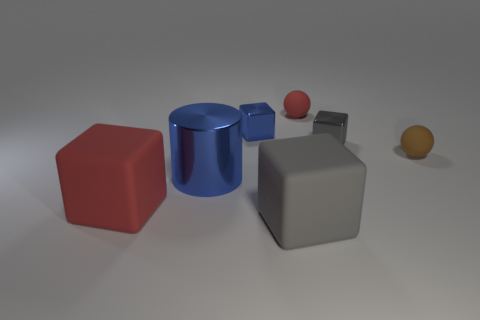There is a tiny gray thing; is its shape the same as the red matte thing that is left of the blue block?
Give a very brief answer. Yes. There is a cube that is left of the large gray thing and in front of the tiny blue block; how big is it?
Your response must be concise. Large. What shape is the tiny gray object?
Your answer should be compact. Cube. There is a matte ball to the left of the tiny brown sphere; is there a cube on the right side of it?
Make the answer very short. Yes. There is a red rubber thing that is left of the blue cylinder; how many large red matte cubes are behind it?
Make the answer very short. 0. What material is the red sphere that is the same size as the blue metallic cube?
Ensure brevity in your answer.  Rubber. Do the small gray thing to the right of the tiny red object and the gray rubber object have the same shape?
Offer a very short reply. Yes. Are there more tiny spheres that are to the left of the tiny gray cube than large red matte objects that are in front of the large gray cube?
Make the answer very short. Yes. How many red blocks have the same material as the small gray cube?
Provide a short and direct response. 0. Do the gray metallic cube and the metallic cylinder have the same size?
Give a very brief answer. No. 